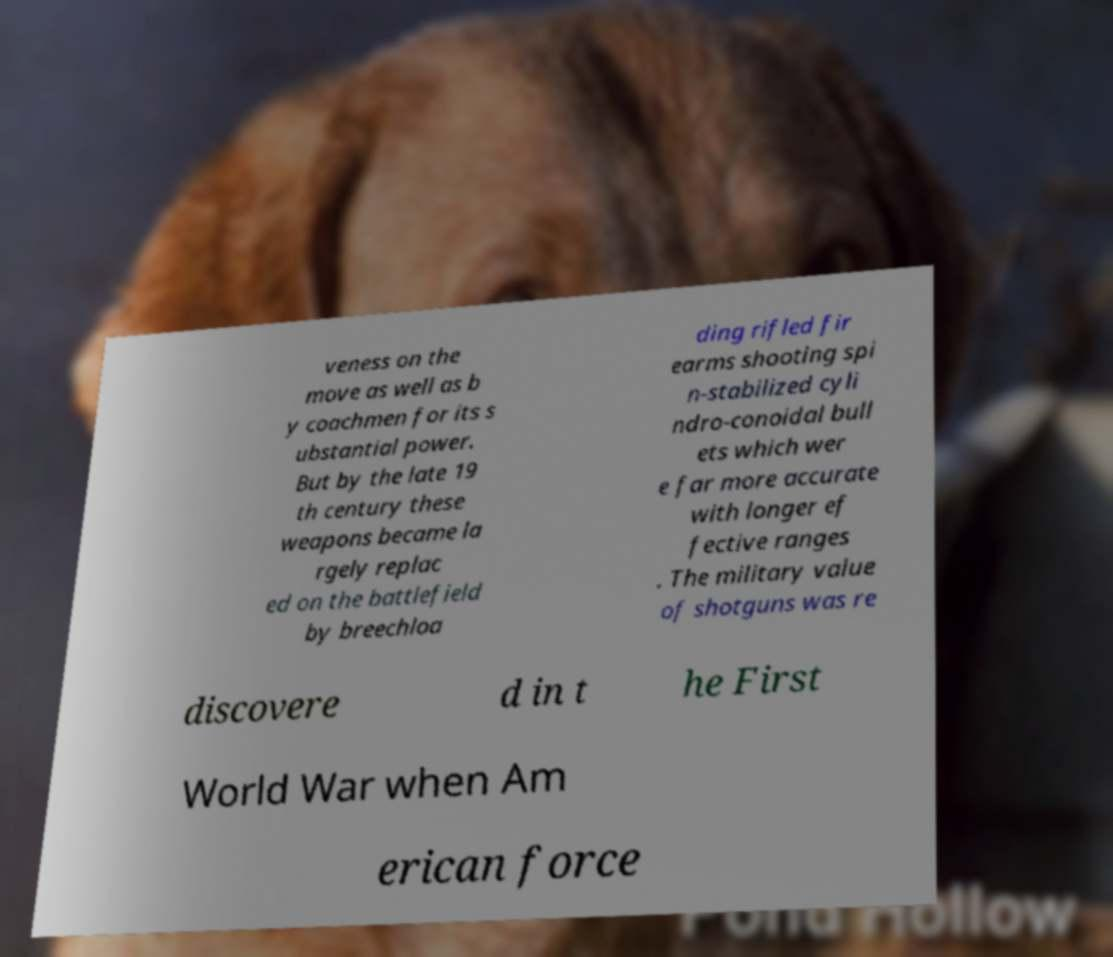Could you extract and type out the text from this image? veness on the move as well as b y coachmen for its s ubstantial power. But by the late 19 th century these weapons became la rgely replac ed on the battlefield by breechloa ding rifled fir earms shooting spi n-stabilized cyli ndro-conoidal bull ets which wer e far more accurate with longer ef fective ranges . The military value of shotguns was re discovere d in t he First World War when Am erican force 